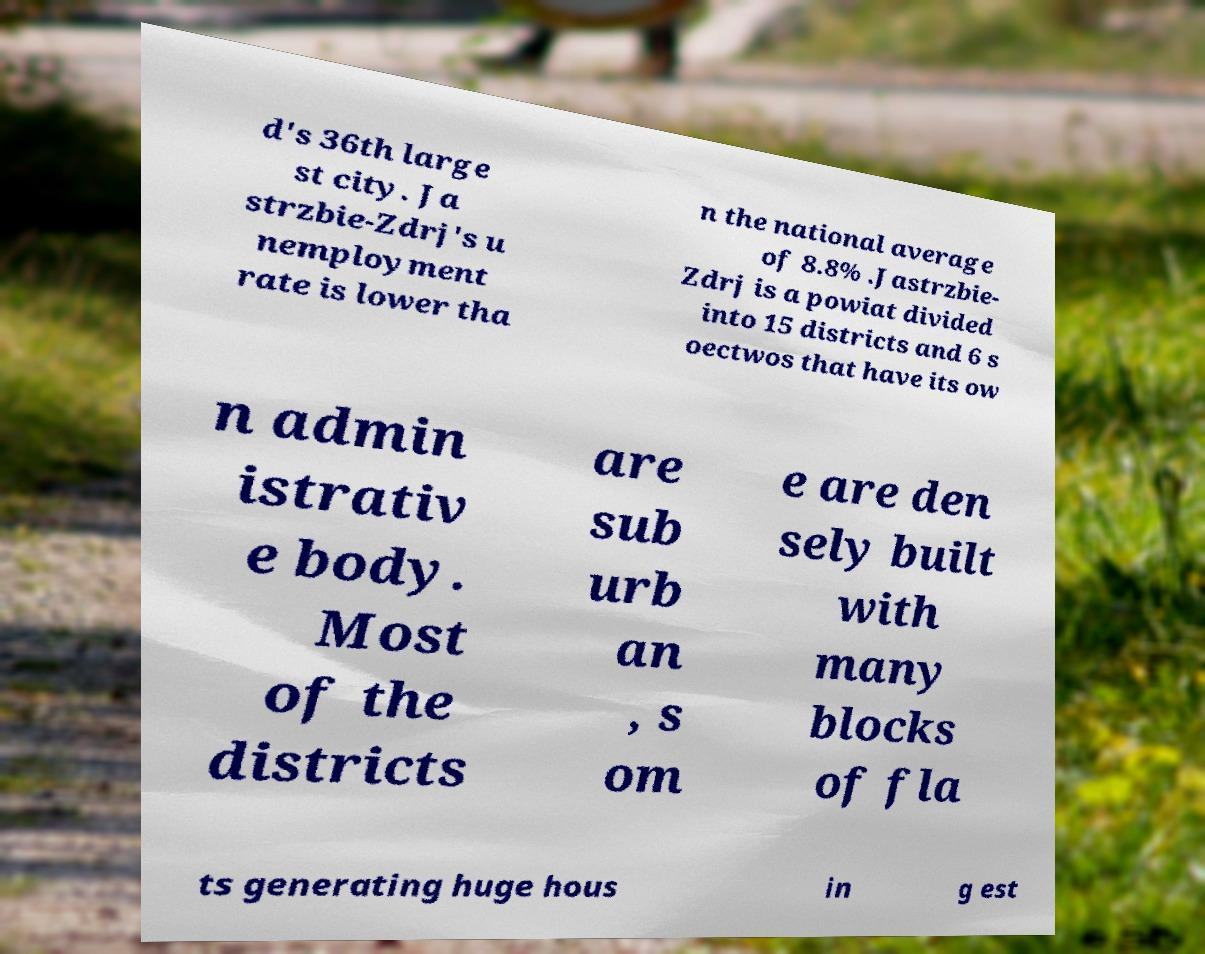Please identify and transcribe the text found in this image. d's 36th large st city. Ja strzbie-Zdrj's u nemployment rate is lower tha n the national average of 8.8% .Jastrzbie- Zdrj is a powiat divided into 15 districts and 6 s oectwos that have its ow n admin istrativ e body. Most of the districts are sub urb an , s om e are den sely built with many blocks of fla ts generating huge hous in g est 